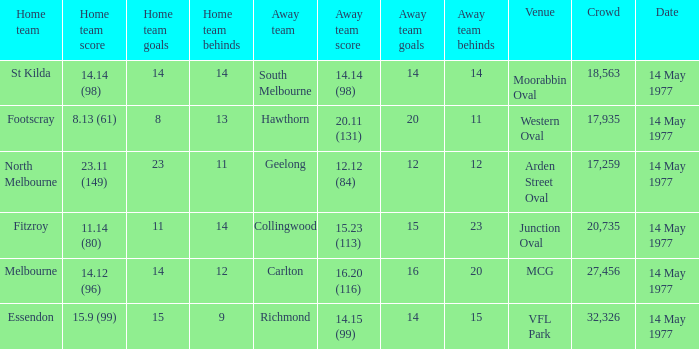I want to know the home team score of the away team of richmond that has a crowd more than 20,735 15.9 (99). 